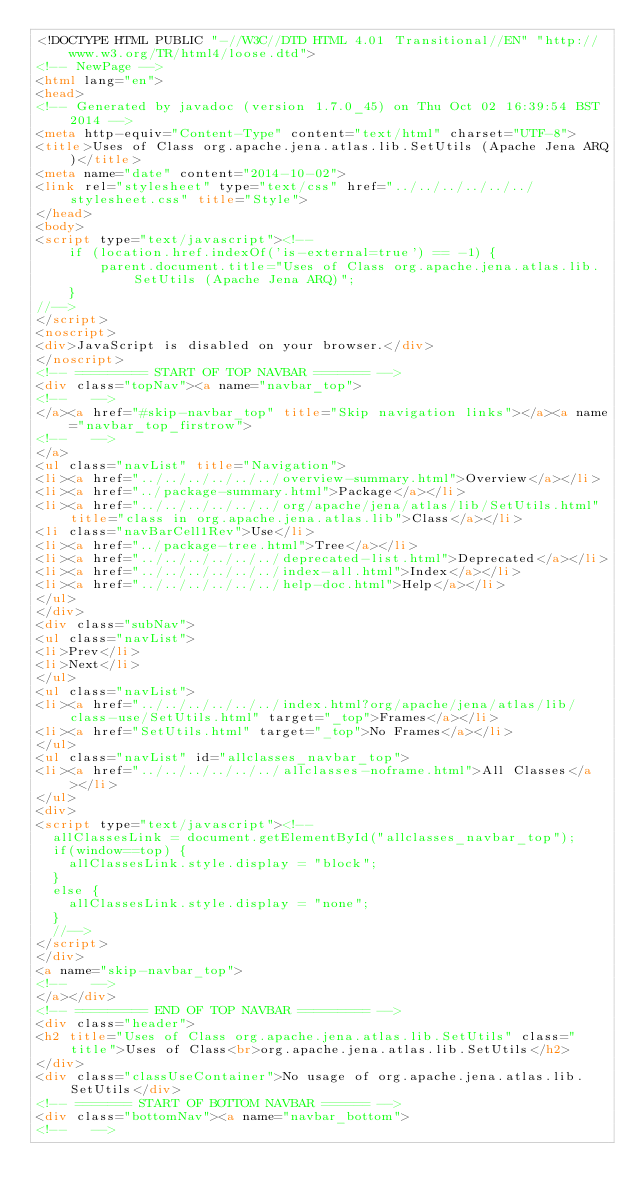<code> <loc_0><loc_0><loc_500><loc_500><_HTML_><!DOCTYPE HTML PUBLIC "-//W3C//DTD HTML 4.01 Transitional//EN" "http://www.w3.org/TR/html4/loose.dtd">
<!-- NewPage -->
<html lang="en">
<head>
<!-- Generated by javadoc (version 1.7.0_45) on Thu Oct 02 16:39:54 BST 2014 -->
<meta http-equiv="Content-Type" content="text/html" charset="UTF-8">
<title>Uses of Class org.apache.jena.atlas.lib.SetUtils (Apache Jena ARQ)</title>
<meta name="date" content="2014-10-02">
<link rel="stylesheet" type="text/css" href="../../../../../../stylesheet.css" title="Style">
</head>
<body>
<script type="text/javascript"><!--
    if (location.href.indexOf('is-external=true') == -1) {
        parent.document.title="Uses of Class org.apache.jena.atlas.lib.SetUtils (Apache Jena ARQ)";
    }
//-->
</script>
<noscript>
<div>JavaScript is disabled on your browser.</div>
</noscript>
<!-- ========= START OF TOP NAVBAR ======= -->
<div class="topNav"><a name="navbar_top">
<!--   -->
</a><a href="#skip-navbar_top" title="Skip navigation links"></a><a name="navbar_top_firstrow">
<!--   -->
</a>
<ul class="navList" title="Navigation">
<li><a href="../../../../../../overview-summary.html">Overview</a></li>
<li><a href="../package-summary.html">Package</a></li>
<li><a href="../../../../../../org/apache/jena/atlas/lib/SetUtils.html" title="class in org.apache.jena.atlas.lib">Class</a></li>
<li class="navBarCell1Rev">Use</li>
<li><a href="../package-tree.html">Tree</a></li>
<li><a href="../../../../../../deprecated-list.html">Deprecated</a></li>
<li><a href="../../../../../../index-all.html">Index</a></li>
<li><a href="../../../../../../help-doc.html">Help</a></li>
</ul>
</div>
<div class="subNav">
<ul class="navList">
<li>Prev</li>
<li>Next</li>
</ul>
<ul class="navList">
<li><a href="../../../../../../index.html?org/apache/jena/atlas/lib/class-use/SetUtils.html" target="_top">Frames</a></li>
<li><a href="SetUtils.html" target="_top">No Frames</a></li>
</ul>
<ul class="navList" id="allclasses_navbar_top">
<li><a href="../../../../../../allclasses-noframe.html">All Classes</a></li>
</ul>
<div>
<script type="text/javascript"><!--
  allClassesLink = document.getElementById("allclasses_navbar_top");
  if(window==top) {
    allClassesLink.style.display = "block";
  }
  else {
    allClassesLink.style.display = "none";
  }
  //-->
</script>
</div>
<a name="skip-navbar_top">
<!--   -->
</a></div>
<!-- ========= END OF TOP NAVBAR ========= -->
<div class="header">
<h2 title="Uses of Class org.apache.jena.atlas.lib.SetUtils" class="title">Uses of Class<br>org.apache.jena.atlas.lib.SetUtils</h2>
</div>
<div class="classUseContainer">No usage of org.apache.jena.atlas.lib.SetUtils</div>
<!-- ======= START OF BOTTOM NAVBAR ====== -->
<div class="bottomNav"><a name="navbar_bottom">
<!--   --></code> 